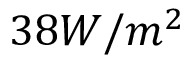Convert formula to latex. <formula><loc_0><loc_0><loc_500><loc_500>3 8 W / m ^ { 2 }</formula> 